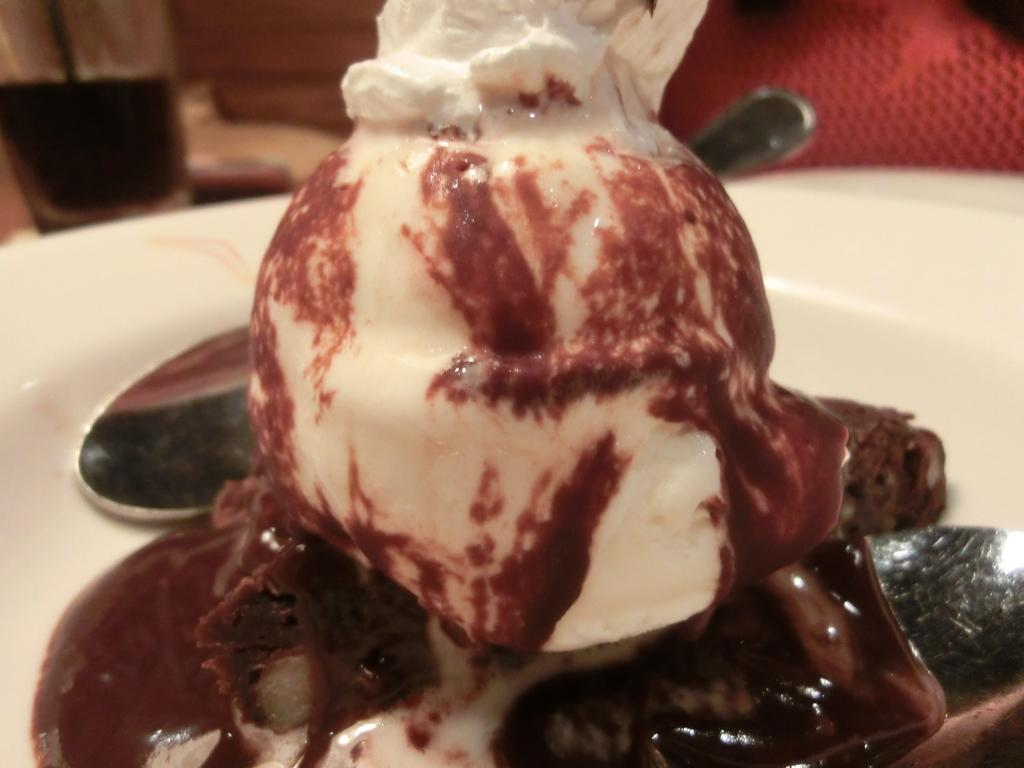What is on top of the cake in the image? There is an ice cream on a piece of cake in the image. What utensils are present on the plate in the image? There are two spoons on a plate in the image. Can you describe the background of the image? There are objects visible in the background of the image, but their specific details are not mentioned in the provided facts. What type of nut can be seen growing on the mountain in the image? There is no mountain or nut present in the image. 